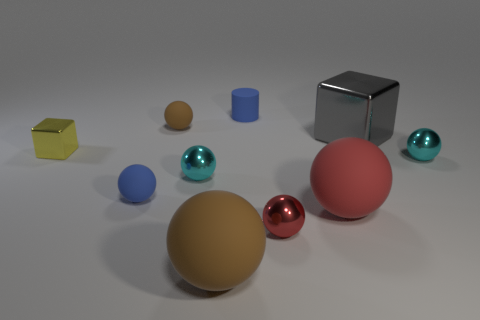Is there anything else of the same color as the cylinder?
Provide a short and direct response. Yes. There is a blue rubber thing that is behind the small brown matte sphere; is its size the same as the cyan thing to the left of the small cylinder?
Keep it short and to the point. Yes. What shape is the cyan metal thing on the right side of the big rubber thing to the left of the large red sphere?
Your response must be concise. Sphere. Do the red matte sphere and the sphere that is on the right side of the big red object have the same size?
Your answer should be very brief. No. What size is the cyan sphere right of the blue matte object that is behind the tiny cyan thing to the left of the small matte cylinder?
Your answer should be very brief. Small. How many objects are either small blue things that are behind the gray metallic cube or big balls?
Provide a succinct answer. 3. There is a small shiny ball to the right of the big gray object; how many blue matte objects are left of it?
Keep it short and to the point. 2. Are there more tiny brown rubber spheres to the right of the big brown thing than balls?
Provide a succinct answer. No. What is the size of the matte thing that is both behind the big metallic block and in front of the cylinder?
Provide a short and direct response. Small. What is the shape of the big thing that is both right of the small rubber cylinder and in front of the large gray metal block?
Give a very brief answer. Sphere. 